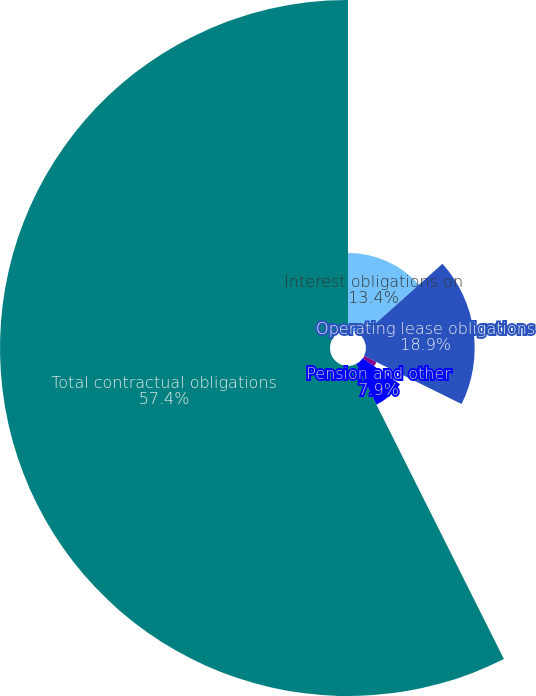Convert chart to OTSL. <chart><loc_0><loc_0><loc_500><loc_500><pie_chart><fcel>Interest obligations on<fcel>Operating lease obligations<fcel>Purchase and marketing<fcel>Pension and other<fcel>Total contractual obligations<nl><fcel>13.4%<fcel>18.9%<fcel>2.4%<fcel>7.9%<fcel>57.39%<nl></chart> 